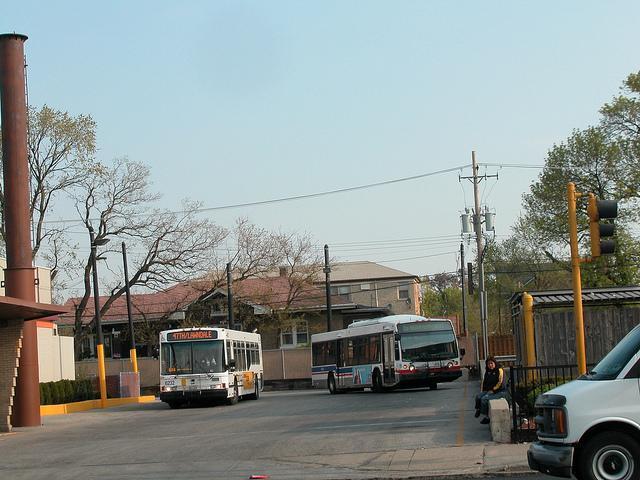How many buses are there?
Give a very brief answer. 2. 